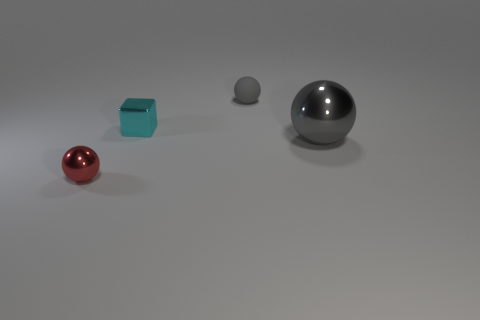Subtract all tiny shiny balls. How many balls are left? 2 Subtract all cyan cylinders. How many gray balls are left? 2 Subtract all blocks. How many objects are left? 3 Add 2 small metal cubes. How many objects exist? 6 Add 2 tiny matte cubes. How many tiny matte cubes exist? 2 Subtract 1 red balls. How many objects are left? 3 Subtract all small cyan metallic cubes. Subtract all small objects. How many objects are left? 0 Add 4 big objects. How many big objects are left? 5 